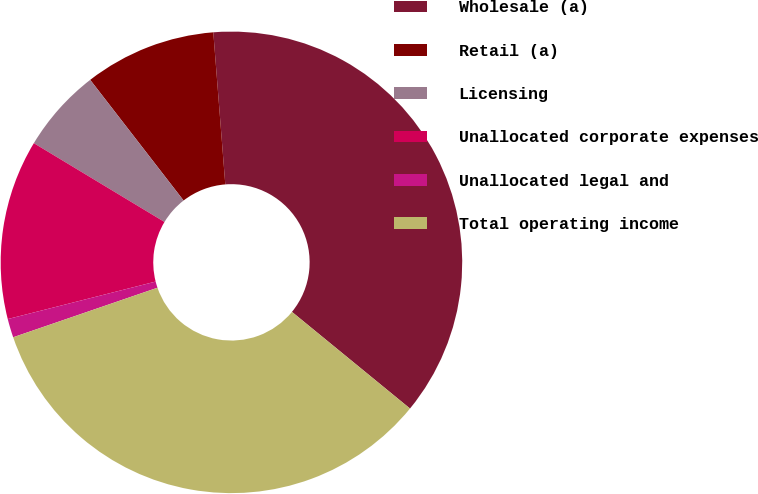Convert chart to OTSL. <chart><loc_0><loc_0><loc_500><loc_500><pie_chart><fcel>Wholesale (a)<fcel>Retail (a)<fcel>Licensing<fcel>Unallocated corporate expenses<fcel>Unallocated legal and<fcel>Total operating income<nl><fcel>37.17%<fcel>9.23%<fcel>5.88%<fcel>12.59%<fcel>1.31%<fcel>33.82%<nl></chart> 